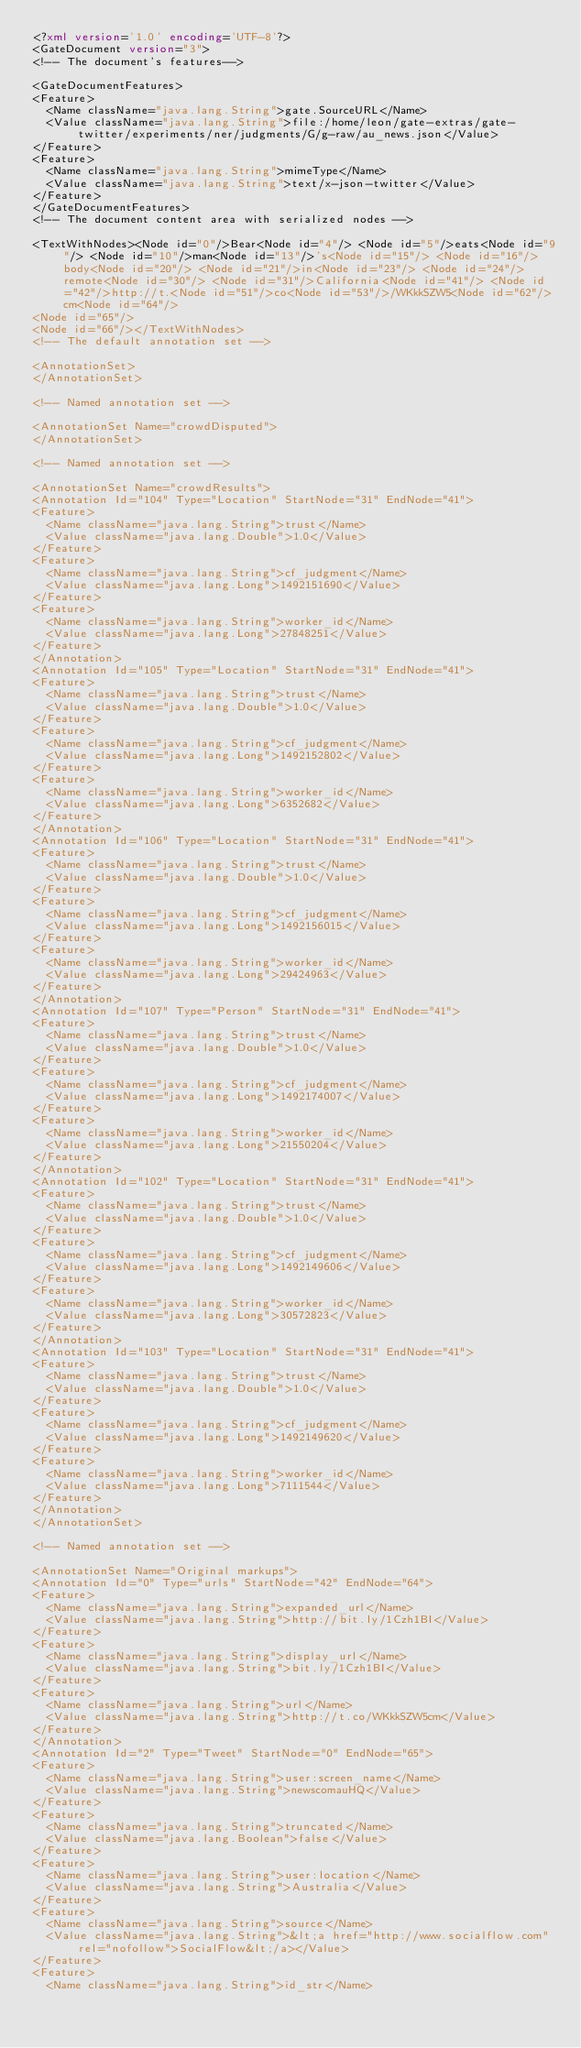Convert code to text. <code><loc_0><loc_0><loc_500><loc_500><_XML_><?xml version='1.0' encoding='UTF-8'?>
<GateDocument version="3">
<!-- The document's features-->

<GateDocumentFeatures>
<Feature>
  <Name className="java.lang.String">gate.SourceURL</Name>
  <Value className="java.lang.String">file:/home/leon/gate-extras/gate-twitter/experiments/ner/judgments/G/g-raw/au_news.json</Value>
</Feature>
<Feature>
  <Name className="java.lang.String">mimeType</Name>
  <Value className="java.lang.String">text/x-json-twitter</Value>
</Feature>
</GateDocumentFeatures>
<!-- The document content area with serialized nodes -->

<TextWithNodes><Node id="0"/>Bear<Node id="4"/> <Node id="5"/>eats<Node id="9"/> <Node id="10"/>man<Node id="13"/>'s<Node id="15"/> <Node id="16"/>body<Node id="20"/> <Node id="21"/>in<Node id="23"/> <Node id="24"/>remote<Node id="30"/> <Node id="31"/>California<Node id="41"/> <Node id="42"/>http://t.<Node id="51"/>co<Node id="53"/>/WKkkSZW5<Node id="62"/>cm<Node id="64"/>
<Node id="65"/>
<Node id="66"/></TextWithNodes>
<!-- The default annotation set -->

<AnnotationSet>
</AnnotationSet>

<!-- Named annotation set -->

<AnnotationSet Name="crowdDisputed">
</AnnotationSet>

<!-- Named annotation set -->

<AnnotationSet Name="crowdResults">
<Annotation Id="104" Type="Location" StartNode="31" EndNode="41">
<Feature>
  <Name className="java.lang.String">trust</Name>
  <Value className="java.lang.Double">1.0</Value>
</Feature>
<Feature>
  <Name className="java.lang.String">cf_judgment</Name>
  <Value className="java.lang.Long">1492151690</Value>
</Feature>
<Feature>
  <Name className="java.lang.String">worker_id</Name>
  <Value className="java.lang.Long">27848251</Value>
</Feature>
</Annotation>
<Annotation Id="105" Type="Location" StartNode="31" EndNode="41">
<Feature>
  <Name className="java.lang.String">trust</Name>
  <Value className="java.lang.Double">1.0</Value>
</Feature>
<Feature>
  <Name className="java.lang.String">cf_judgment</Name>
  <Value className="java.lang.Long">1492152802</Value>
</Feature>
<Feature>
  <Name className="java.lang.String">worker_id</Name>
  <Value className="java.lang.Long">6352682</Value>
</Feature>
</Annotation>
<Annotation Id="106" Type="Location" StartNode="31" EndNode="41">
<Feature>
  <Name className="java.lang.String">trust</Name>
  <Value className="java.lang.Double">1.0</Value>
</Feature>
<Feature>
  <Name className="java.lang.String">cf_judgment</Name>
  <Value className="java.lang.Long">1492156015</Value>
</Feature>
<Feature>
  <Name className="java.lang.String">worker_id</Name>
  <Value className="java.lang.Long">29424963</Value>
</Feature>
</Annotation>
<Annotation Id="107" Type="Person" StartNode="31" EndNode="41">
<Feature>
  <Name className="java.lang.String">trust</Name>
  <Value className="java.lang.Double">1.0</Value>
</Feature>
<Feature>
  <Name className="java.lang.String">cf_judgment</Name>
  <Value className="java.lang.Long">1492174007</Value>
</Feature>
<Feature>
  <Name className="java.lang.String">worker_id</Name>
  <Value className="java.lang.Long">21550204</Value>
</Feature>
</Annotation>
<Annotation Id="102" Type="Location" StartNode="31" EndNode="41">
<Feature>
  <Name className="java.lang.String">trust</Name>
  <Value className="java.lang.Double">1.0</Value>
</Feature>
<Feature>
  <Name className="java.lang.String">cf_judgment</Name>
  <Value className="java.lang.Long">1492149606</Value>
</Feature>
<Feature>
  <Name className="java.lang.String">worker_id</Name>
  <Value className="java.lang.Long">30572823</Value>
</Feature>
</Annotation>
<Annotation Id="103" Type="Location" StartNode="31" EndNode="41">
<Feature>
  <Name className="java.lang.String">trust</Name>
  <Value className="java.lang.Double">1.0</Value>
</Feature>
<Feature>
  <Name className="java.lang.String">cf_judgment</Name>
  <Value className="java.lang.Long">1492149620</Value>
</Feature>
<Feature>
  <Name className="java.lang.String">worker_id</Name>
  <Value className="java.lang.Long">7111544</Value>
</Feature>
</Annotation>
</AnnotationSet>

<!-- Named annotation set -->

<AnnotationSet Name="Original markups">
<Annotation Id="0" Type="urls" StartNode="42" EndNode="64">
<Feature>
  <Name className="java.lang.String">expanded_url</Name>
  <Value className="java.lang.String">http://bit.ly/1Czh1BI</Value>
</Feature>
<Feature>
  <Name className="java.lang.String">display_url</Name>
  <Value className="java.lang.String">bit.ly/1Czh1BI</Value>
</Feature>
<Feature>
  <Name className="java.lang.String">url</Name>
  <Value className="java.lang.String">http://t.co/WKkkSZW5cm</Value>
</Feature>
</Annotation>
<Annotation Id="2" Type="Tweet" StartNode="0" EndNode="65">
<Feature>
  <Name className="java.lang.String">user:screen_name</Name>
  <Value className="java.lang.String">newscomauHQ</Value>
</Feature>
<Feature>
  <Name className="java.lang.String">truncated</Name>
  <Value className="java.lang.Boolean">false</Value>
</Feature>
<Feature>
  <Name className="java.lang.String">user:location</Name>
  <Value className="java.lang.String">Australia</Value>
</Feature>
<Feature>
  <Name className="java.lang.String">source</Name>
  <Value className="java.lang.String">&lt;a href="http://www.socialflow.com" rel="nofollow">SocialFlow&lt;/a></Value>
</Feature>
<Feature>
  <Name className="java.lang.String">id_str</Name></code> 